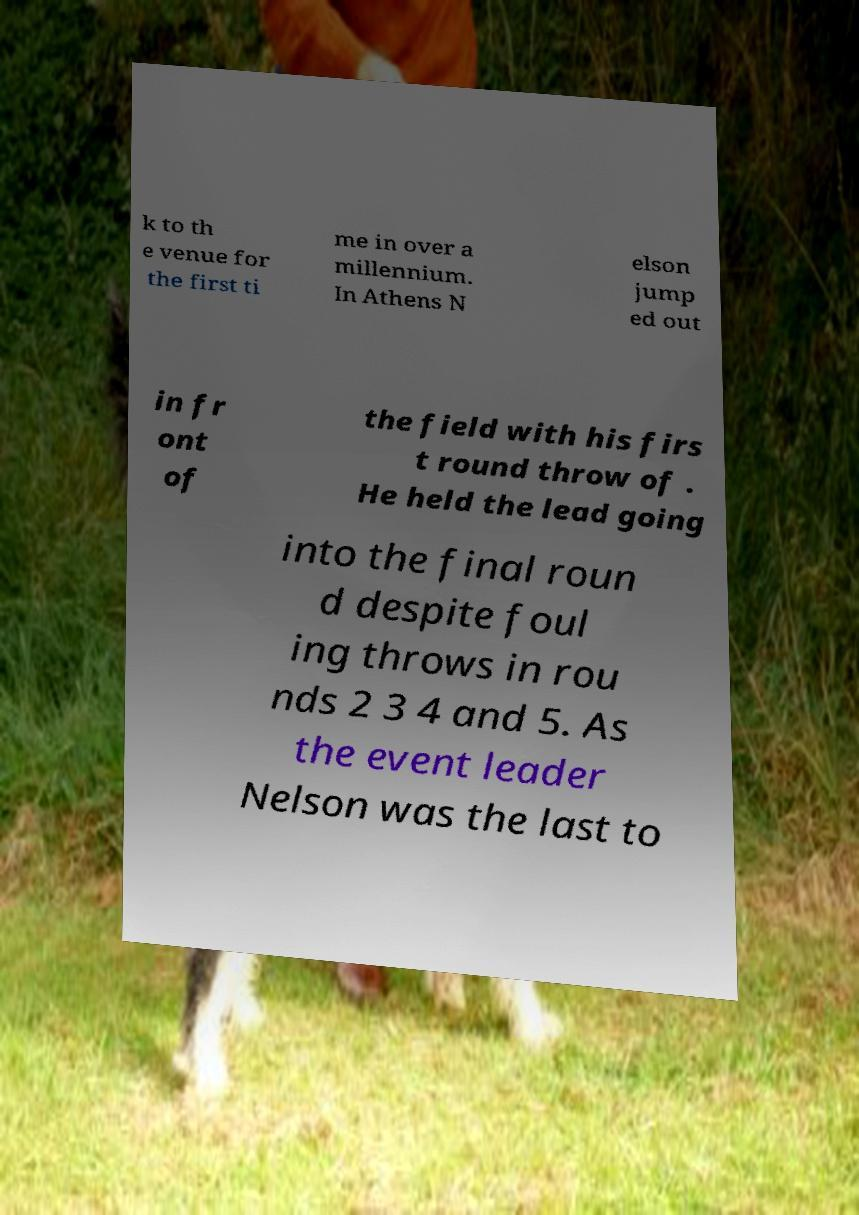Could you assist in decoding the text presented in this image and type it out clearly? k to th e venue for the first ti me in over a millennium. In Athens N elson jump ed out in fr ont of the field with his firs t round throw of . He held the lead going into the final roun d despite foul ing throws in rou nds 2 3 4 and 5. As the event leader Nelson was the last to 